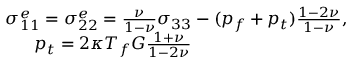<formula> <loc_0><loc_0><loc_500><loc_500>\begin{array} { r } { \sigma _ { 1 1 } ^ { e } = \sigma _ { 2 2 } ^ { e } = \frac { \nu } { 1 - \nu } \sigma _ { 3 3 } - ( p _ { f } + p _ { t } ) \frac { 1 - 2 \nu } { 1 - \nu } , } \\ { p _ { t } = 2 \kappa T _ { f } G \frac { 1 + \nu } { 1 - 2 \nu } \quad } \end{array}</formula> 